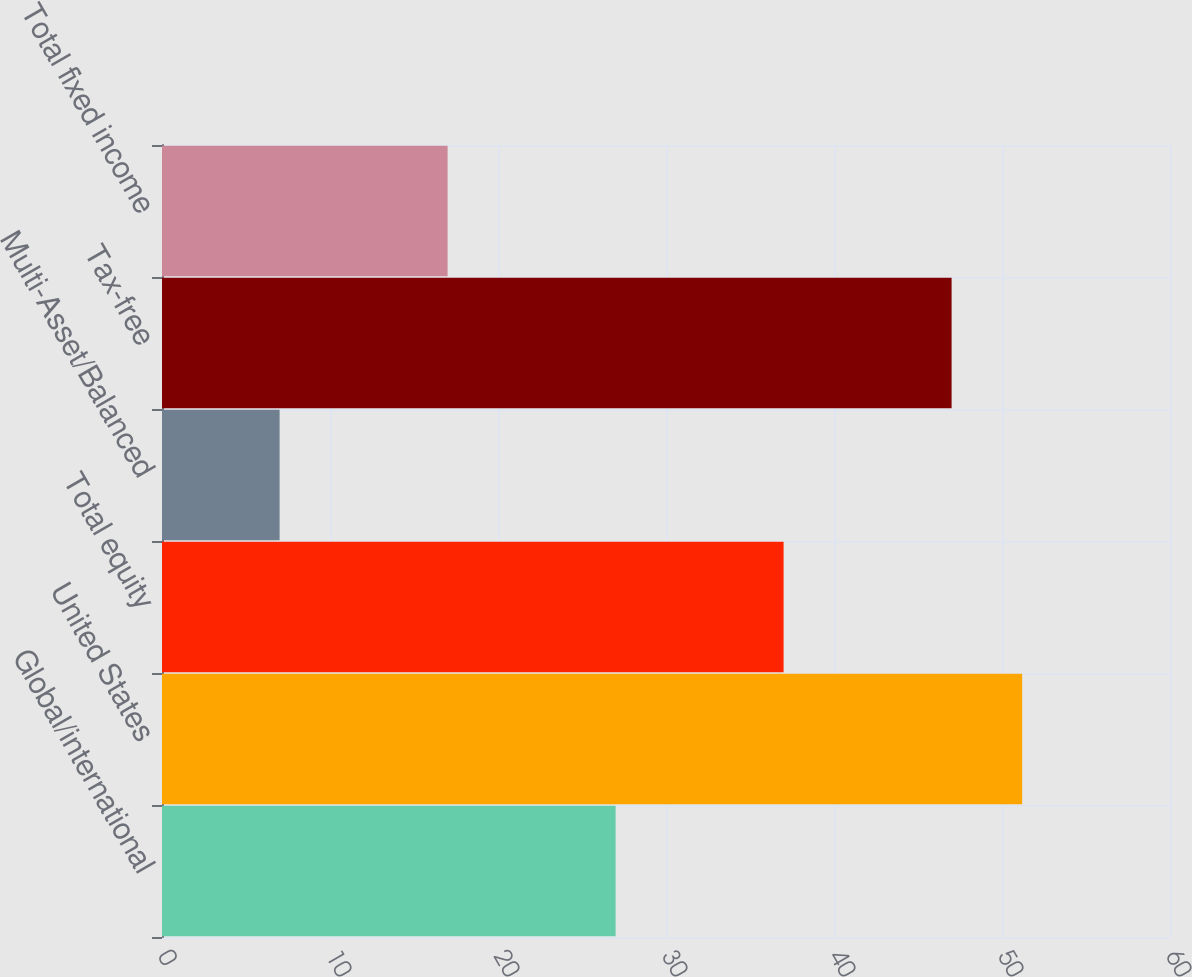<chart> <loc_0><loc_0><loc_500><loc_500><bar_chart><fcel>Global/international<fcel>United States<fcel>Total equity<fcel>Multi-Asset/Balanced<fcel>Tax-free<fcel>Total fixed income<nl><fcel>27<fcel>51.2<fcel>37<fcel>7<fcel>47<fcel>17<nl></chart> 